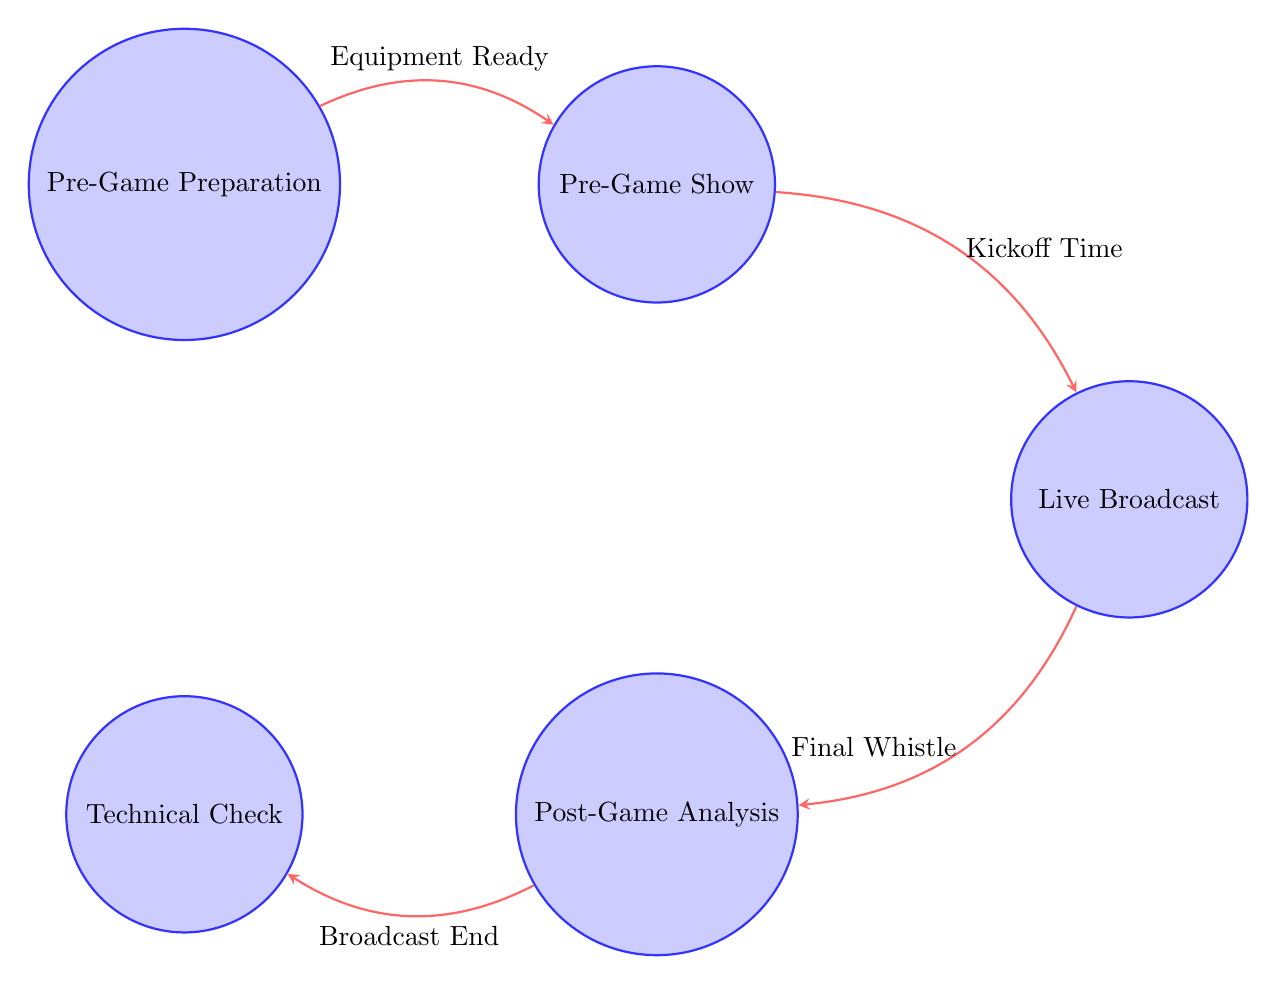What is the first state in the diagram? The first state is labeled "Pre-Game Preparation" at the top left of the diagram.
Answer: Pre-Game Preparation How many states are present in the diagram? The diagram displays five distinct states, which are Pre-Game Preparation, Pre-Game Show, Live Broadcast, Post-Game Analysis, and Technical Check.
Answer: Five What action is associated with the Pre-Game Preparation state? The actions listed under the Pre-Game Preparation state include "Set Up Equipment," "Test Broadcast System," and "Coordinate with Stadium Staff."
Answer: Set Up Equipment What triggers the transition from Pre-Game Preparation to Pre-Game Show? According to the diagram, the transition from Pre-Game Preparation to Pre-Game Show is triggered when the equipment is ready.
Answer: Equipment Ready After the Live Broadcast, which state does the diagram transition to? The diagram shows that after the Live Broadcast state, it transitions to the Post-Game Analysis state upon the Final Whistle occurring.
Answer: Post-Game Analysis How many transitions are illustrated in the diagram? The diagram illustrates four transitions connecting the five states, establishing a clear flow of the broadcasting process.
Answer: Four What is the last state in the progression of the diagram? The last state in the sequence is Technical Check, which follows the Post-Game Analysis state after the broadcast ends.
Answer: Technical Check Which state includes the action "Expert Commentary"? The action "Expert Commentary" is associated with the Post-Game Analysis state, where the detailed evaluation of the game takes place.
Answer: Post-Game Analysis What is the relationship between the Live Broadcast and Post-Game Analysis states? The relationship is a direct transition where the end of the Live Broadcast, marked by the Final Whistle, leads to the beginning of Post-Game Analysis.
Answer: Direct transition 